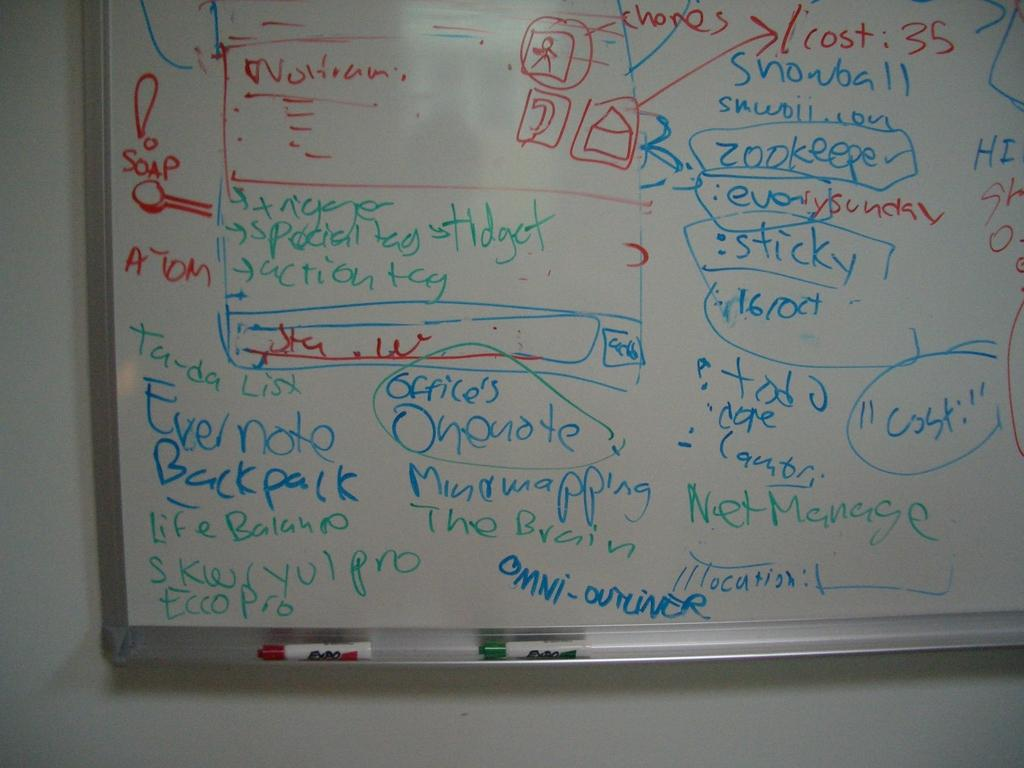Provide a one-sentence caption for the provided image. White board includes names and diagrams with expo markers. 